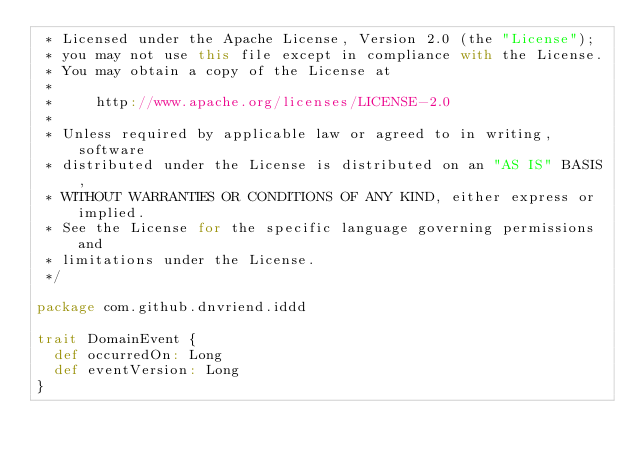<code> <loc_0><loc_0><loc_500><loc_500><_Scala_> * Licensed under the Apache License, Version 2.0 (the "License");
 * you may not use this file except in compliance with the License.
 * You may obtain a copy of the License at
 *
 *     http://www.apache.org/licenses/LICENSE-2.0
 *
 * Unless required by applicable law or agreed to in writing, software
 * distributed under the License is distributed on an "AS IS" BASIS,
 * WITHOUT WARRANTIES OR CONDITIONS OF ANY KIND, either express or implied.
 * See the License for the specific language governing permissions and
 * limitations under the License.
 */

package com.github.dnvriend.iddd

trait DomainEvent {
  def occurredOn: Long
  def eventVersion: Long
}
</code> 